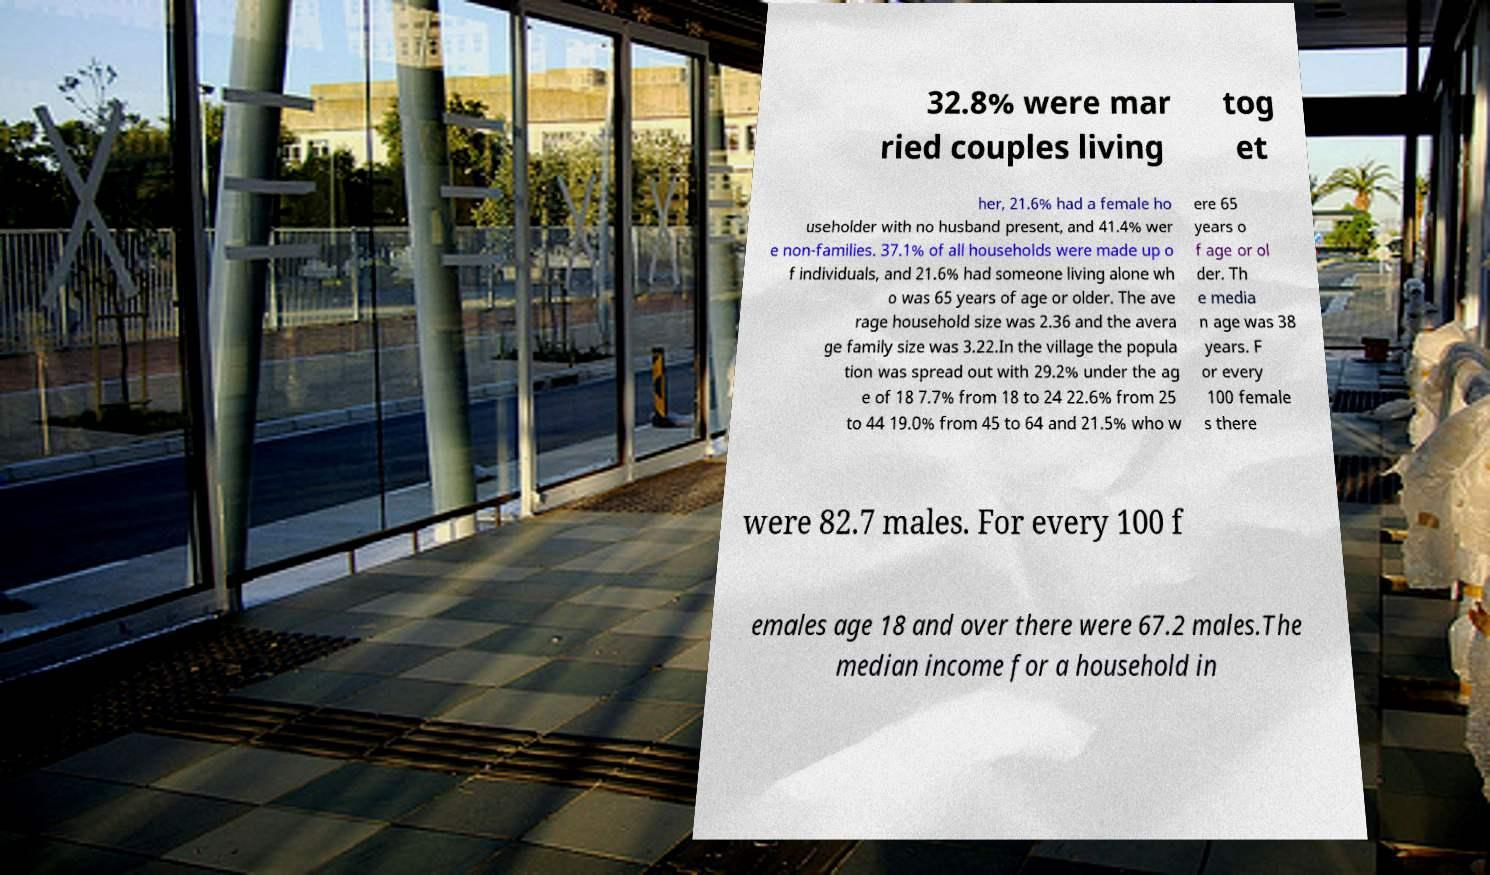For documentation purposes, I need the text within this image transcribed. Could you provide that? 32.8% were mar ried couples living tog et her, 21.6% had a female ho useholder with no husband present, and 41.4% wer e non-families. 37.1% of all households were made up o f individuals, and 21.6% had someone living alone wh o was 65 years of age or older. The ave rage household size was 2.36 and the avera ge family size was 3.22.In the village the popula tion was spread out with 29.2% under the ag e of 18 7.7% from 18 to 24 22.6% from 25 to 44 19.0% from 45 to 64 and 21.5% who w ere 65 years o f age or ol der. Th e media n age was 38 years. F or every 100 female s there were 82.7 males. For every 100 f emales age 18 and over there were 67.2 males.The median income for a household in 